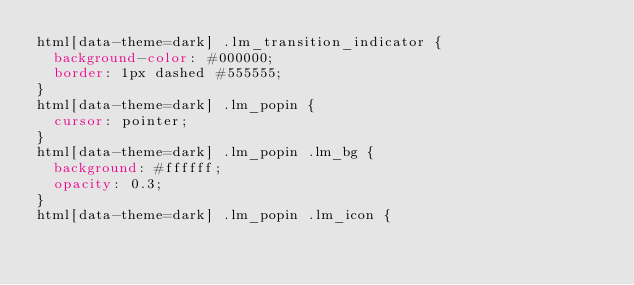<code> <loc_0><loc_0><loc_500><loc_500><_CSS_>html[data-theme=dark] .lm_transition_indicator {
  background-color: #000000;
  border: 1px dashed #555555;
}
html[data-theme=dark] .lm_popin {
  cursor: pointer;
}
html[data-theme=dark] .lm_popin .lm_bg {
  background: #ffffff;
  opacity: 0.3;
}
html[data-theme=dark] .lm_popin .lm_icon {</code> 